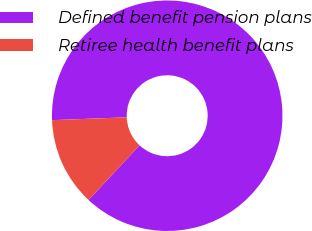Convert chart. <chart><loc_0><loc_0><loc_500><loc_500><pie_chart><fcel>Defined benefit pension plans<fcel>Retiree health benefit plans<nl><fcel>87.57%<fcel>12.43%<nl></chart> 